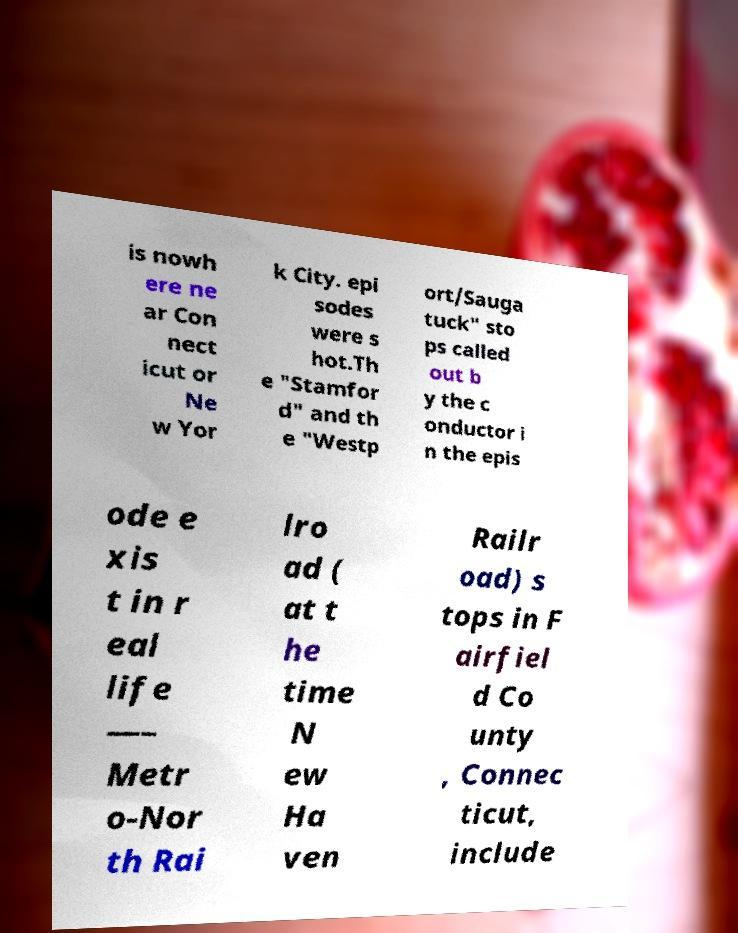What messages or text are displayed in this image? I need them in a readable, typed format. is nowh ere ne ar Con nect icut or Ne w Yor k City. epi sodes were s hot.Th e "Stamfor d" and th e "Westp ort/Sauga tuck" sto ps called out b y the c onductor i n the epis ode e xis t in r eal life —– Metr o-Nor th Rai lro ad ( at t he time N ew Ha ven Railr oad) s tops in F airfiel d Co unty , Connec ticut, include 